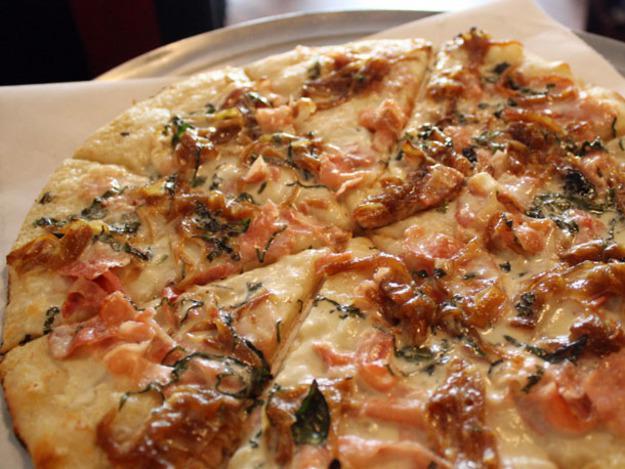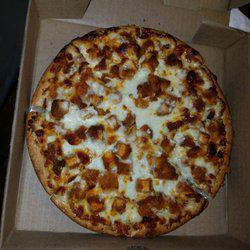The first image is the image on the left, the second image is the image on the right. Considering the images on both sides, is "The left image shows a tool with a handle and a flat metal part being applied to a round pizza." valid? Answer yes or no. No. The first image is the image on the left, the second image is the image on the right. Given the left and right images, does the statement "The left and right image contains the same number of pizzas with at least on sitting on paper." hold true? Answer yes or no. Yes. 